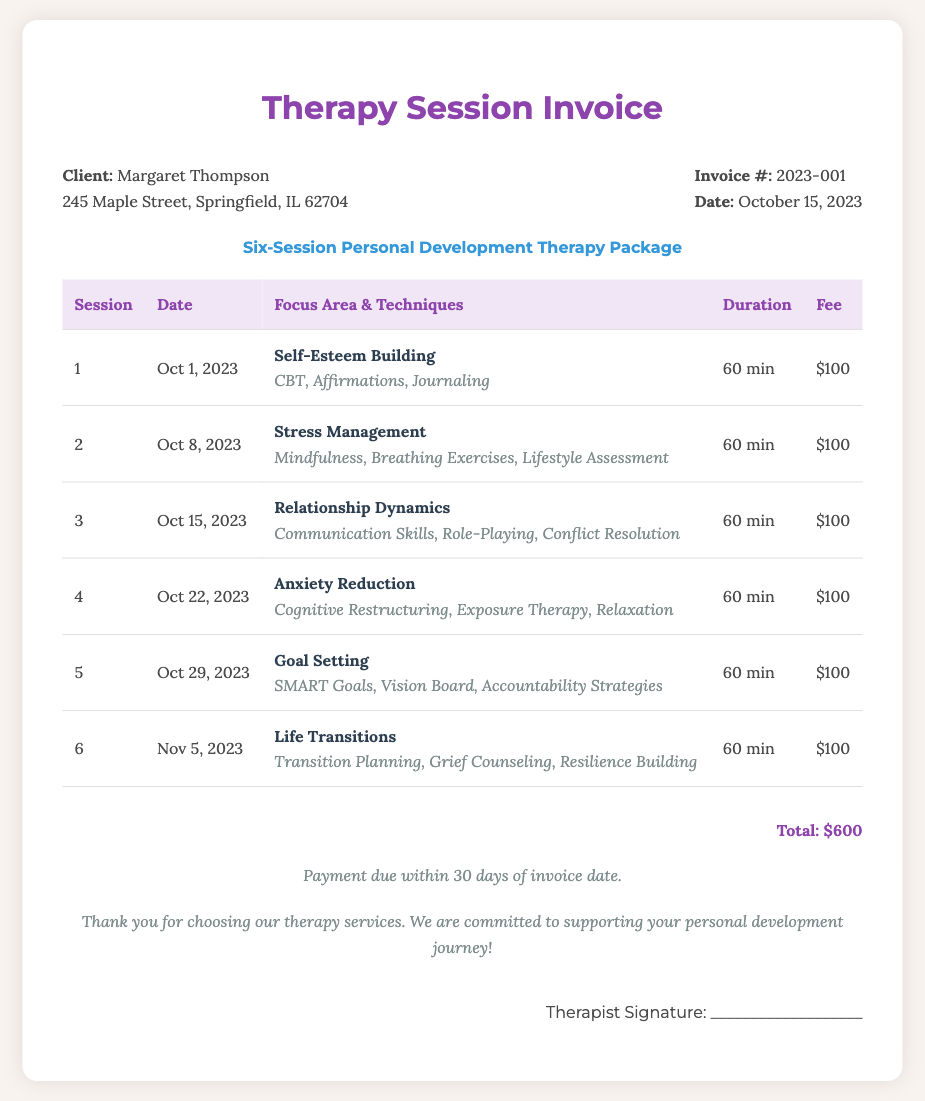What is the name of the client? The client's name is provided in the document.
Answer: Margaret Thompson What is the invoice number? The invoice number can be found in the document details.
Answer: 2023-001 How many sessions are included in the therapy package? The document clearly states the number of sessions included in the package.
Answer: Six What is the total fee for the therapy sessions? The total fee is provided at the bottom of the invoice.
Answer: $600 What is the focus area of the third session? The third session's focus area is detailed in the session table.
Answer: Relationship Dynamics What techniques are used in the second session? The techniques for the second session are listed in the session detail.
Answer: Mindfulness, Breathing Exercises, Lifestyle Assessment What is the duration of each session? The duration of each session is uniformly noted in the table.
Answer: 60 min On what date is the fifth session scheduled? The date for the fifth session is specified in the date column of the table.
Answer: Oct 29, 2023 What payment terms are mentioned in the document? The payment terms are outlined at the bottom of the invoice.
Answer: Payment due within 30 days of invoice date 